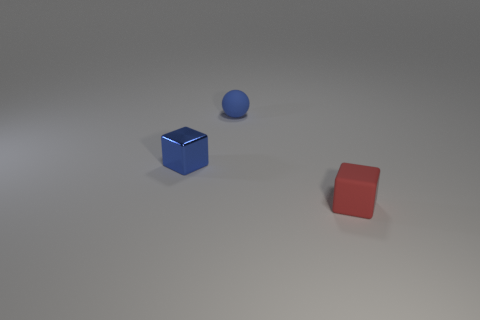Are there any other things that have the same material as the blue cube?
Your answer should be very brief. No. Is there any other thing that has the same shape as the blue rubber object?
Provide a succinct answer. No. What number of blocks are either small things or small red things?
Your answer should be compact. 2. What is the material of the other thing that is the same color as the small shiny object?
Your response must be concise. Rubber. There is a rubber cube; does it have the same color as the small object behind the blue metal cube?
Your response must be concise. No. The small matte block has what color?
Make the answer very short. Red. What number of things are brown matte cylinders or blue rubber objects?
Give a very brief answer. 1. There is a blue thing that is the same size as the ball; what material is it?
Make the answer very short. Metal. What size is the matte object that is left of the red block?
Your response must be concise. Small. What material is the tiny blue cube?
Give a very brief answer. Metal. 